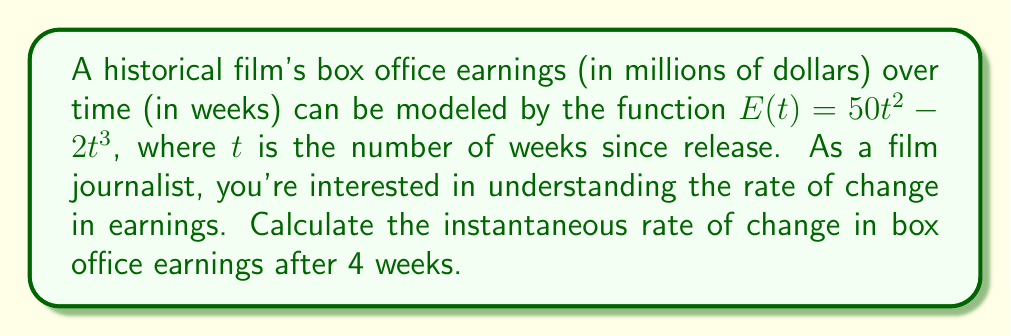What is the answer to this math problem? To find the instantaneous rate of change, we need to calculate the derivative of the earnings function and evaluate it at $t = 4$ weeks.

Step 1: Find the derivative of $E(t)$
$$\frac{d}{dt}E(t) = \frac{d}{dt}(50t^2 - 2t^3)$$
Using the power rule:
$$E'(t) = 100t - 6t^2$$

Step 2: Evaluate $E'(t)$ at $t = 4$
$$E'(4) = 100(4) - 6(4^2)$$
$$E'(4) = 400 - 6(16)$$
$$E'(4) = 400 - 96$$
$$E'(4) = 304$$

The instantaneous rate of change after 4 weeks is 304 million dollars per week.
Answer: $304$ million dollars per week 